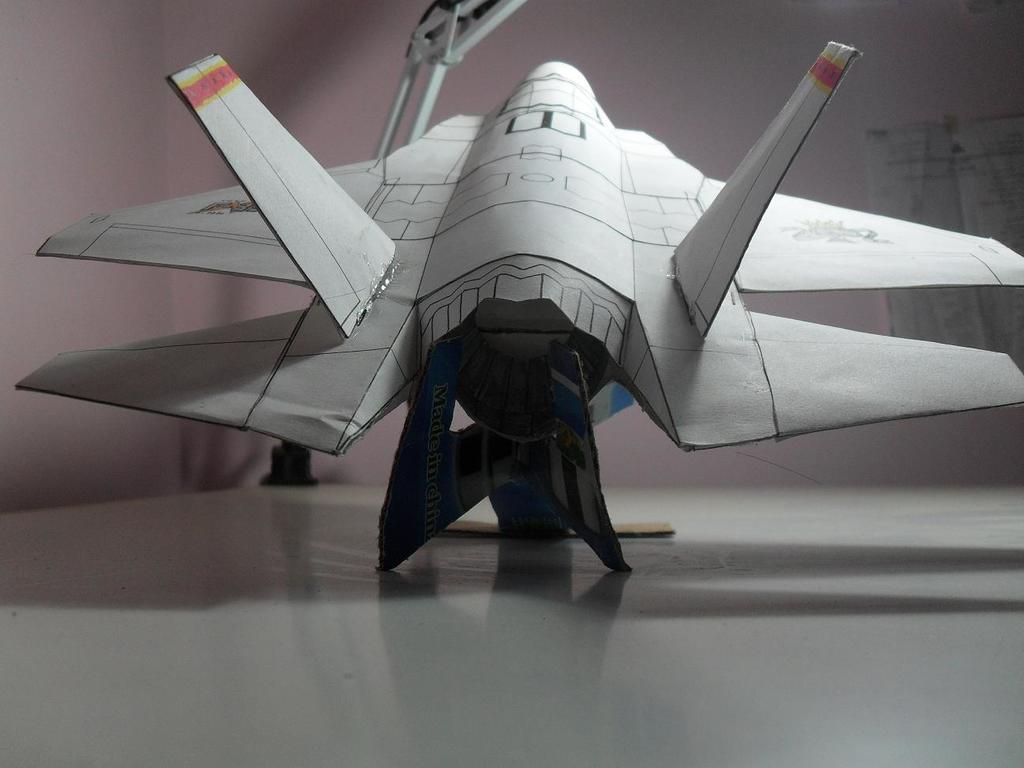Can you describe this image briefly? This picture seems to be clicked inside. In the center there is an object seems to be an aircraft which is placed on the top of a surface of an object. In the background we can see the wall. 